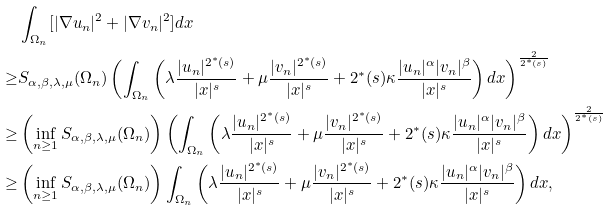Convert formula to latex. <formula><loc_0><loc_0><loc_500><loc_500>& \int _ { \Omega _ { n } } [ | \nabla u _ { n } | ^ { 2 } + | \nabla v _ { n } | ^ { 2 } ] d x \\ \geq & S _ { \alpha , \beta , \lambda , \mu } ( \Omega _ { n } ) \left ( \int _ { \Omega _ { n } } \left ( \lambda \frac { | u _ { n } | ^ { 2 ^ { * } ( s ) } } { | x | ^ { s } } + \mu \frac { | v _ { n } | ^ { 2 ^ { * } ( s ) } } { | x | ^ { s } } + 2 ^ { * } ( s ) \kappa \frac { | u _ { n } | ^ { \alpha } | v _ { n } | ^ { \beta } } { | x | ^ { s } } \right ) d x \right ) ^ { \frac { 2 } { 2 ^ { * } ( s ) } } \\ \geq & \left ( \inf _ { n \geq 1 } S _ { \alpha , \beta , \lambda , \mu } ( \Omega _ { n } ) \right ) \left ( \int _ { \Omega _ { n } } \left ( \lambda \frac { | u _ { n } | ^ { 2 ^ { * } ( s ) } } { | x | ^ { s } } + \mu \frac { | v _ { n } | ^ { 2 ^ { * } ( s ) } } { | x | ^ { s } } + 2 ^ { * } ( s ) \kappa \frac { | u _ { n } | ^ { \alpha } | v _ { n } | ^ { \beta } } { | x | ^ { s } } \right ) d x \right ) ^ { \frac { 2 } { 2 ^ { * } ( s ) } } \\ \geq & \left ( \inf _ { n \geq 1 } S _ { \alpha , \beta , \lambda , \mu } ( \Omega _ { n } ) \right ) \int _ { \Omega _ { n } } \left ( \lambda \frac { | u _ { n } | ^ { 2 ^ { * } ( s ) } } { | x | ^ { s } } + \mu \frac { | v _ { n } | ^ { 2 ^ { * } ( s ) } } { | x | ^ { s } } + 2 ^ { * } ( s ) \kappa \frac { | u _ { n } | ^ { \alpha } | v _ { n } | ^ { \beta } } { | x | ^ { s } } \right ) d x ,</formula> 